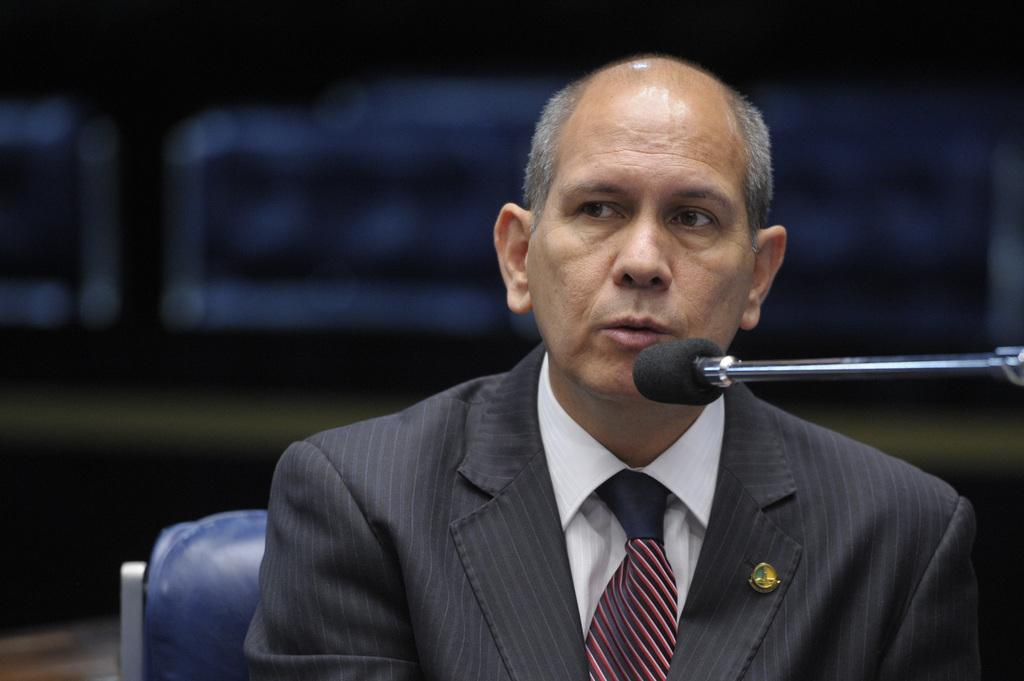Who or what is the main subject of the image? There is a person in the image. What is the person doing in the image? The person is sitting in a chair. What object is in front of the person? There is a microphone (mic) in front of the person. What type of group is performing in the image? There is no group performing in the image; it only shows a person sitting in a chair with a microphone in front of them. Who is the owner of the microphone in the image? There is no information about the ownership of the microphone in the image. 